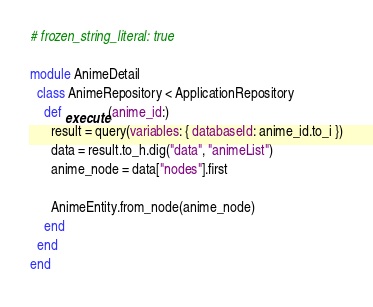Convert code to text. <code><loc_0><loc_0><loc_500><loc_500><_Ruby_># frozen_string_literal: true

module AnimeDetail
  class AnimeRepository < ApplicationRepository
    def execute(anime_id:)
      result = query(variables: { databaseId: anime_id.to_i })
      data = result.to_h.dig("data", "animeList")
      anime_node = data["nodes"].first

      AnimeEntity.from_node(anime_node)
    end
  end
end
</code> 